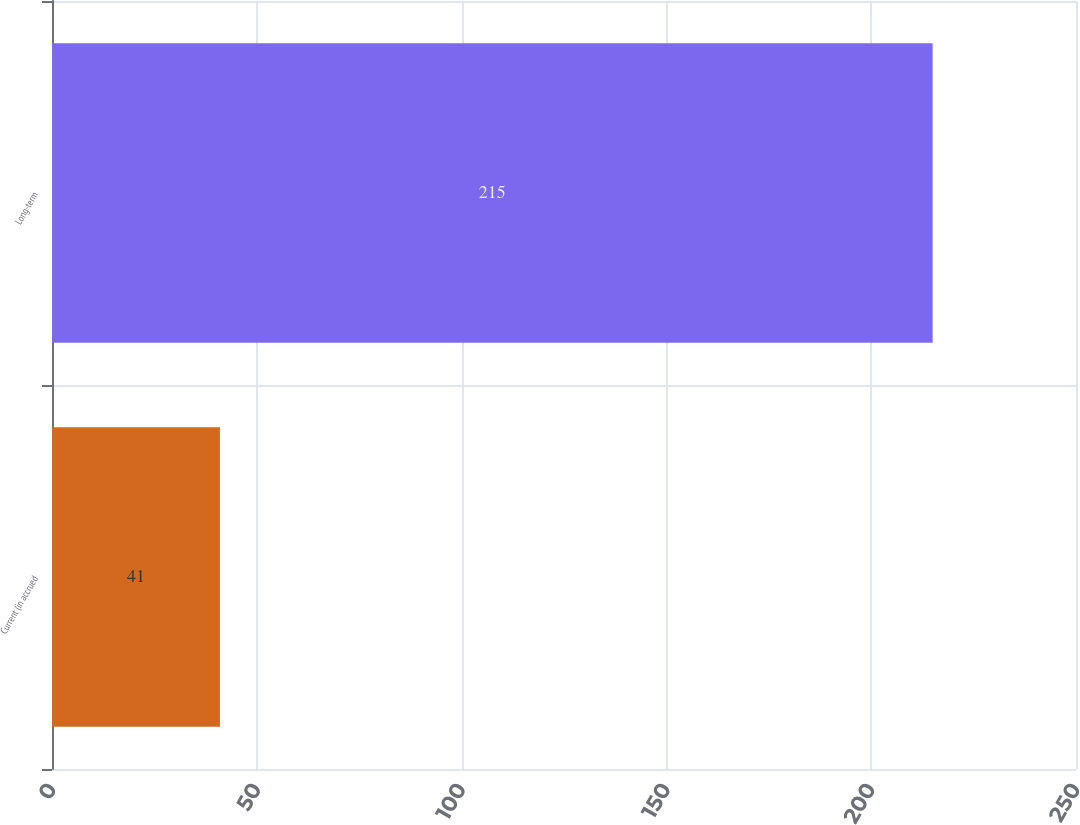<chart> <loc_0><loc_0><loc_500><loc_500><bar_chart><fcel>Current (in accrued<fcel>Long-term<nl><fcel>41<fcel>215<nl></chart> 